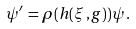<formula> <loc_0><loc_0><loc_500><loc_500>\psi ^ { \prime } \, = \rho ( h ( \xi \, , g ) ) \psi \, .</formula> 